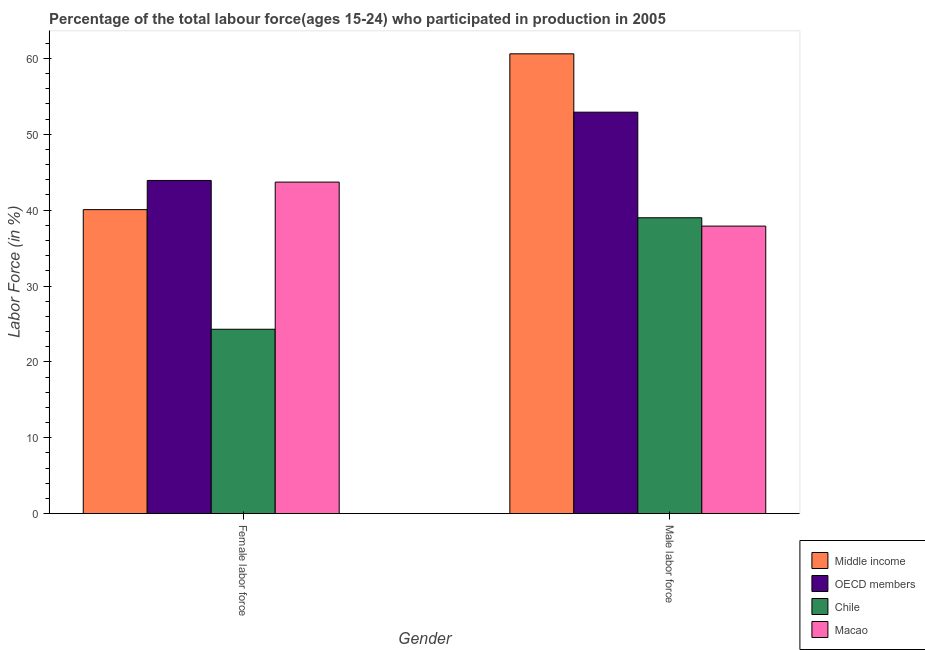Are the number of bars per tick equal to the number of legend labels?
Offer a terse response. Yes. How many bars are there on the 1st tick from the left?
Offer a very short reply. 4. What is the label of the 2nd group of bars from the left?
Your response must be concise. Male labor force. What is the percentage of female labor force in Middle income?
Offer a terse response. 40.07. Across all countries, what is the maximum percentage of male labour force?
Keep it short and to the point. 60.61. Across all countries, what is the minimum percentage of female labor force?
Offer a terse response. 24.3. In which country was the percentage of male labour force minimum?
Provide a succinct answer. Macao. What is the total percentage of male labour force in the graph?
Offer a terse response. 190.43. What is the difference between the percentage of female labor force in Macao and that in Middle income?
Your answer should be compact. 3.63. What is the difference between the percentage of male labour force in Chile and the percentage of female labor force in Middle income?
Provide a short and direct response. -1.07. What is the average percentage of male labour force per country?
Your answer should be compact. 47.61. What is the difference between the percentage of female labor force and percentage of male labour force in Macao?
Make the answer very short. 5.8. What is the ratio of the percentage of male labour force in Macao to that in Chile?
Provide a succinct answer. 0.97. Is the percentage of male labour force in Middle income less than that in Chile?
Keep it short and to the point. No. In how many countries, is the percentage of female labor force greater than the average percentage of female labor force taken over all countries?
Offer a very short reply. 3. What does the 4th bar from the left in Female labor force represents?
Ensure brevity in your answer.  Macao. What does the 3rd bar from the right in Male labor force represents?
Ensure brevity in your answer.  OECD members. How many bars are there?
Your answer should be very brief. 8. Are all the bars in the graph horizontal?
Keep it short and to the point. No. What is the difference between two consecutive major ticks on the Y-axis?
Your response must be concise. 10. Are the values on the major ticks of Y-axis written in scientific E-notation?
Your answer should be compact. No. Does the graph contain any zero values?
Ensure brevity in your answer.  No. Does the graph contain grids?
Offer a terse response. No. Where does the legend appear in the graph?
Make the answer very short. Bottom right. What is the title of the graph?
Give a very brief answer. Percentage of the total labour force(ages 15-24) who participated in production in 2005. What is the Labor Force (in %) of Middle income in Female labor force?
Provide a succinct answer. 40.07. What is the Labor Force (in %) of OECD members in Female labor force?
Ensure brevity in your answer.  43.92. What is the Labor Force (in %) in Chile in Female labor force?
Ensure brevity in your answer.  24.3. What is the Labor Force (in %) in Macao in Female labor force?
Provide a short and direct response. 43.7. What is the Labor Force (in %) of Middle income in Male labor force?
Make the answer very short. 60.61. What is the Labor Force (in %) of OECD members in Male labor force?
Your response must be concise. 52.92. What is the Labor Force (in %) in Chile in Male labor force?
Provide a succinct answer. 39. What is the Labor Force (in %) in Macao in Male labor force?
Ensure brevity in your answer.  37.9. Across all Gender, what is the maximum Labor Force (in %) in Middle income?
Keep it short and to the point. 60.61. Across all Gender, what is the maximum Labor Force (in %) in OECD members?
Ensure brevity in your answer.  52.92. Across all Gender, what is the maximum Labor Force (in %) of Chile?
Make the answer very short. 39. Across all Gender, what is the maximum Labor Force (in %) in Macao?
Make the answer very short. 43.7. Across all Gender, what is the minimum Labor Force (in %) of Middle income?
Ensure brevity in your answer.  40.07. Across all Gender, what is the minimum Labor Force (in %) of OECD members?
Make the answer very short. 43.92. Across all Gender, what is the minimum Labor Force (in %) of Chile?
Give a very brief answer. 24.3. Across all Gender, what is the minimum Labor Force (in %) in Macao?
Offer a very short reply. 37.9. What is the total Labor Force (in %) of Middle income in the graph?
Your answer should be very brief. 100.68. What is the total Labor Force (in %) of OECD members in the graph?
Provide a succinct answer. 96.84. What is the total Labor Force (in %) in Chile in the graph?
Give a very brief answer. 63.3. What is the total Labor Force (in %) in Macao in the graph?
Make the answer very short. 81.6. What is the difference between the Labor Force (in %) of Middle income in Female labor force and that in Male labor force?
Ensure brevity in your answer.  -20.54. What is the difference between the Labor Force (in %) in OECD members in Female labor force and that in Male labor force?
Keep it short and to the point. -9. What is the difference between the Labor Force (in %) in Chile in Female labor force and that in Male labor force?
Your answer should be very brief. -14.7. What is the difference between the Labor Force (in %) of Macao in Female labor force and that in Male labor force?
Your answer should be very brief. 5.8. What is the difference between the Labor Force (in %) in Middle income in Female labor force and the Labor Force (in %) in OECD members in Male labor force?
Ensure brevity in your answer.  -12.85. What is the difference between the Labor Force (in %) of Middle income in Female labor force and the Labor Force (in %) of Chile in Male labor force?
Provide a short and direct response. 1.07. What is the difference between the Labor Force (in %) of Middle income in Female labor force and the Labor Force (in %) of Macao in Male labor force?
Your answer should be compact. 2.17. What is the difference between the Labor Force (in %) of OECD members in Female labor force and the Labor Force (in %) of Chile in Male labor force?
Offer a terse response. 4.92. What is the difference between the Labor Force (in %) of OECD members in Female labor force and the Labor Force (in %) of Macao in Male labor force?
Keep it short and to the point. 6.02. What is the difference between the Labor Force (in %) of Chile in Female labor force and the Labor Force (in %) of Macao in Male labor force?
Provide a succinct answer. -13.6. What is the average Labor Force (in %) of Middle income per Gender?
Keep it short and to the point. 50.34. What is the average Labor Force (in %) of OECD members per Gender?
Offer a very short reply. 48.42. What is the average Labor Force (in %) of Chile per Gender?
Keep it short and to the point. 31.65. What is the average Labor Force (in %) of Macao per Gender?
Your answer should be compact. 40.8. What is the difference between the Labor Force (in %) of Middle income and Labor Force (in %) of OECD members in Female labor force?
Ensure brevity in your answer.  -3.85. What is the difference between the Labor Force (in %) of Middle income and Labor Force (in %) of Chile in Female labor force?
Your response must be concise. 15.77. What is the difference between the Labor Force (in %) of Middle income and Labor Force (in %) of Macao in Female labor force?
Provide a short and direct response. -3.63. What is the difference between the Labor Force (in %) in OECD members and Labor Force (in %) in Chile in Female labor force?
Offer a terse response. 19.62. What is the difference between the Labor Force (in %) of OECD members and Labor Force (in %) of Macao in Female labor force?
Provide a short and direct response. 0.22. What is the difference between the Labor Force (in %) of Chile and Labor Force (in %) of Macao in Female labor force?
Ensure brevity in your answer.  -19.4. What is the difference between the Labor Force (in %) of Middle income and Labor Force (in %) of OECD members in Male labor force?
Give a very brief answer. 7.7. What is the difference between the Labor Force (in %) of Middle income and Labor Force (in %) of Chile in Male labor force?
Make the answer very short. 21.61. What is the difference between the Labor Force (in %) of Middle income and Labor Force (in %) of Macao in Male labor force?
Ensure brevity in your answer.  22.71. What is the difference between the Labor Force (in %) of OECD members and Labor Force (in %) of Chile in Male labor force?
Keep it short and to the point. 13.92. What is the difference between the Labor Force (in %) of OECD members and Labor Force (in %) of Macao in Male labor force?
Offer a very short reply. 15.02. What is the ratio of the Labor Force (in %) of Middle income in Female labor force to that in Male labor force?
Ensure brevity in your answer.  0.66. What is the ratio of the Labor Force (in %) of OECD members in Female labor force to that in Male labor force?
Your response must be concise. 0.83. What is the ratio of the Labor Force (in %) in Chile in Female labor force to that in Male labor force?
Give a very brief answer. 0.62. What is the ratio of the Labor Force (in %) in Macao in Female labor force to that in Male labor force?
Your answer should be compact. 1.15. What is the difference between the highest and the second highest Labor Force (in %) in Middle income?
Your answer should be compact. 20.54. What is the difference between the highest and the second highest Labor Force (in %) in OECD members?
Give a very brief answer. 9. What is the difference between the highest and the second highest Labor Force (in %) in Macao?
Your response must be concise. 5.8. What is the difference between the highest and the lowest Labor Force (in %) in Middle income?
Your answer should be very brief. 20.54. What is the difference between the highest and the lowest Labor Force (in %) of OECD members?
Your answer should be compact. 9. What is the difference between the highest and the lowest Labor Force (in %) of Chile?
Offer a very short reply. 14.7. What is the difference between the highest and the lowest Labor Force (in %) in Macao?
Keep it short and to the point. 5.8. 